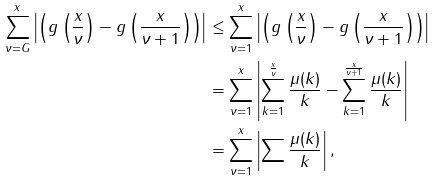Convert formula to latex. <formula><loc_0><loc_0><loc_500><loc_500>\sum _ { \nu = G } ^ { x } \left | \left ( g \left ( \frac { x } { \nu } \right ) - g \left ( \frac { x } { \nu + 1 } \right ) \right ) \right | & \leq \sum _ { \nu = 1 } ^ { x } \left | \left ( g \left ( \frac { x } { \nu } \right ) - g \left ( \frac { x } { \nu + 1 } \right ) \right ) \right | \\ & = \sum _ { \nu = 1 } ^ { x } \left | \sum _ { k = 1 } ^ { \frac { x } { \nu } } \frac { \mu ( k ) } { k } - \sum _ { k = 1 } ^ { \frac { x } { \nu + 1 } } \frac { \mu ( k ) } { k } \right | \\ & = \sum _ { \nu = 1 } ^ { x } \left | \sum \frac { \mu ( k ) } { k } \right | ,</formula> 